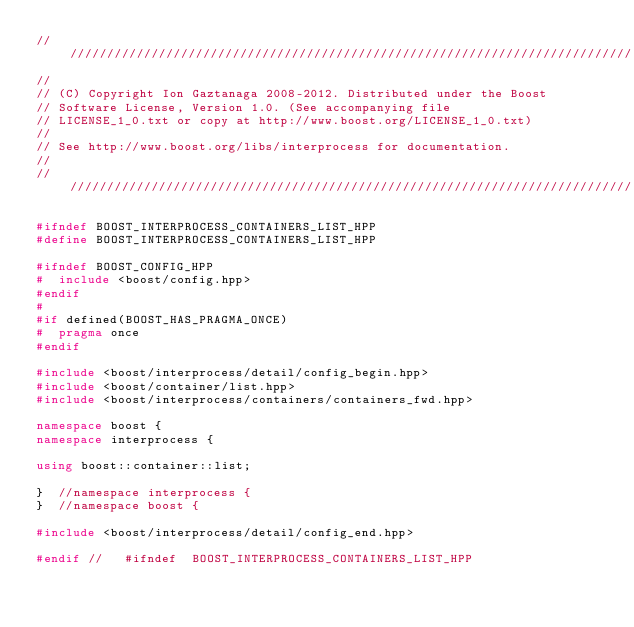Convert code to text. <code><loc_0><loc_0><loc_500><loc_500><_C++_>//////////////////////////////////////////////////////////////////////////////
//
// (C) Copyright Ion Gaztanaga 2008-2012. Distributed under the Boost
// Software License, Version 1.0. (See accompanying file
// LICENSE_1_0.txt or copy at http://www.boost.org/LICENSE_1_0.txt)
//
// See http://www.boost.org/libs/interprocess for documentation.
//
//////////////////////////////////////////////////////////////////////////////

#ifndef BOOST_INTERPROCESS_CONTAINERS_LIST_HPP
#define BOOST_INTERPROCESS_CONTAINERS_LIST_HPP

#ifndef BOOST_CONFIG_HPP
#  include <boost/config.hpp>
#endif
#
#if defined(BOOST_HAS_PRAGMA_ONCE)
#  pragma once
#endif

#include <boost/interprocess/detail/config_begin.hpp>
#include <boost/container/list.hpp>
#include <boost/interprocess/containers/containers_fwd.hpp>

namespace boost {
namespace interprocess {

using boost::container::list;

}  //namespace interprocess {
}  //namespace boost {

#include <boost/interprocess/detail/config_end.hpp>

#endif //   #ifndef  BOOST_INTERPROCESS_CONTAINERS_LIST_HPP

</code> 